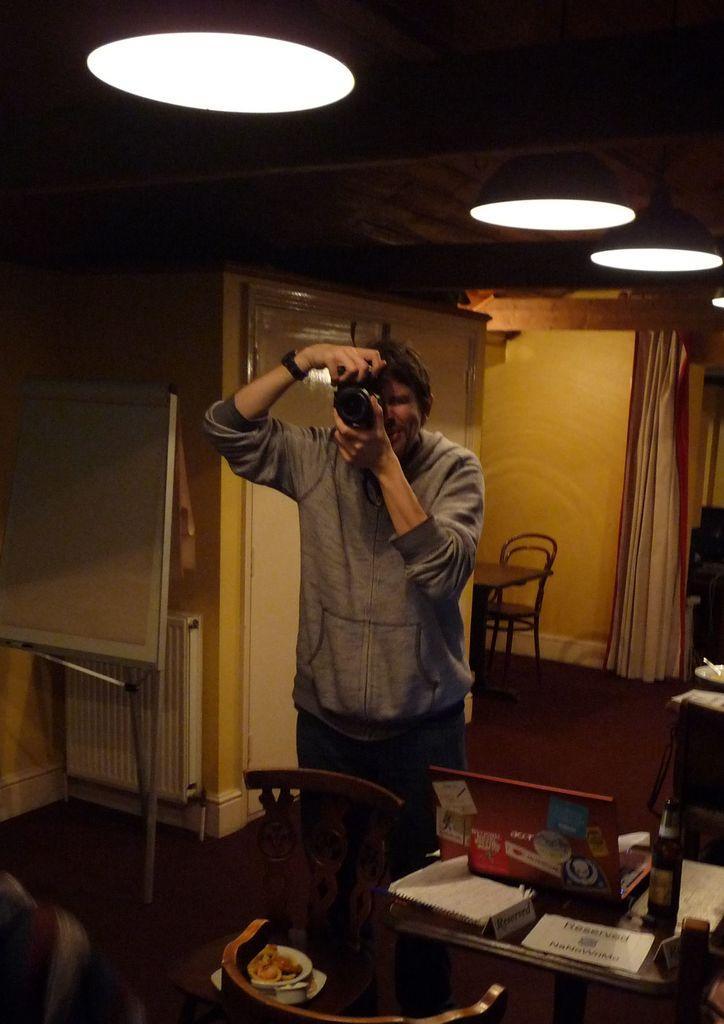Please provide a concise description of this image. In the image there is a man standing and clicking a photo with the camera, beside him there is a table and on the table there are some objects, on the left side there is a white board and behind the man there is a table and a chair, a curtain, wall and there are lights fixed to the roof. 